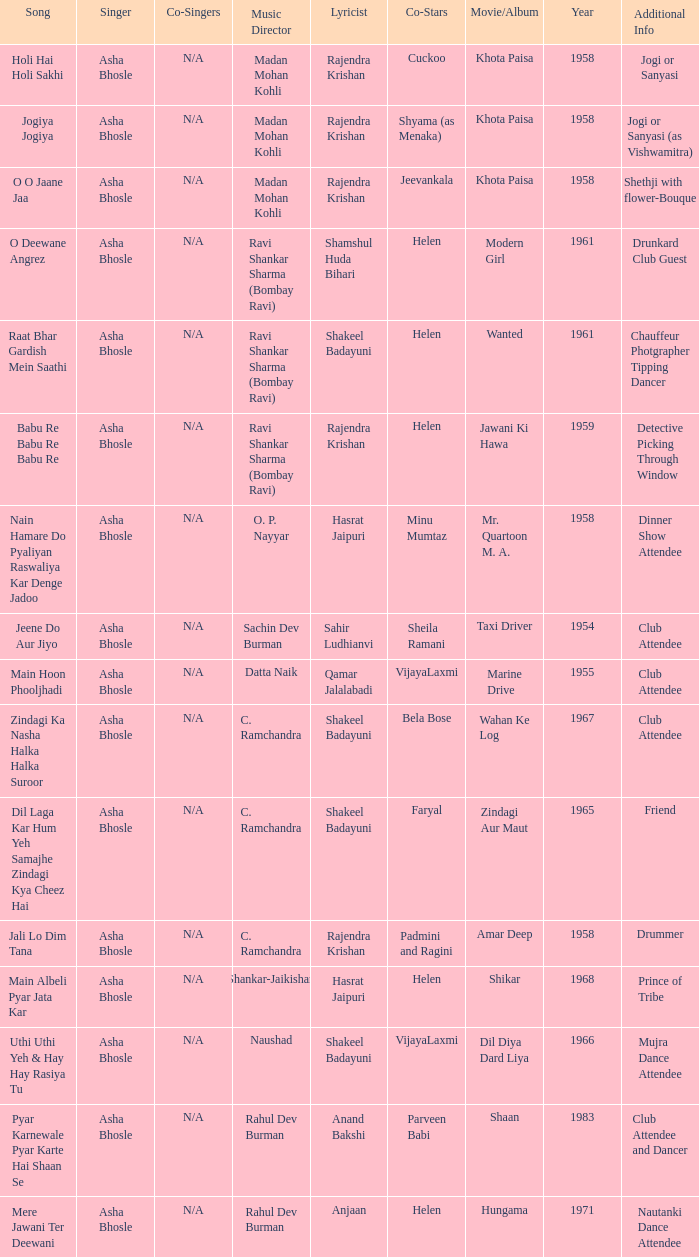Who authored the verses when jeevankala co-acted? Rajendra Krishan. Write the full table. {'header': ['Song', 'Singer', 'Co-Singers', 'Music Director', 'Lyricist', 'Co-Stars', 'Movie/Album', 'Year', 'Additional Info'], 'rows': [['Holi Hai Holi Sakhi', 'Asha Bhosle', 'N/A', 'Madan Mohan Kohli', 'Rajendra Krishan', 'Cuckoo', 'Khota Paisa', '1958', 'Jogi or Sanyasi'], ['Jogiya Jogiya', 'Asha Bhosle', 'N/A', 'Madan Mohan Kohli', 'Rajendra Krishan', 'Shyama (as Menaka)', 'Khota Paisa', '1958', 'Jogi or Sanyasi (as Vishwamitra)'], ['O O Jaane Jaa', 'Asha Bhosle', 'N/A', 'Madan Mohan Kohli', 'Rajendra Krishan', 'Jeevankala', 'Khota Paisa', '1958', 'Shethji with flower-Bouque'], ['O Deewane Angrez', 'Asha Bhosle', 'N/A', 'Ravi Shankar Sharma (Bombay Ravi)', 'Shamshul Huda Bihari', 'Helen', 'Modern Girl', '1961', 'Drunkard Club Guest'], ['Raat Bhar Gardish Mein Saathi', 'Asha Bhosle', 'N/A', 'Ravi Shankar Sharma (Bombay Ravi)', 'Shakeel Badayuni', 'Helen', 'Wanted', '1961', 'Chauffeur Photgrapher Tipping Dancer'], ['Babu Re Babu Re Babu Re', 'Asha Bhosle', 'N/A', 'Ravi Shankar Sharma (Bombay Ravi)', 'Rajendra Krishan', 'Helen', 'Jawani Ki Hawa', '1959', 'Detective Picking Through Window'], ['Nain Hamare Do Pyaliyan Raswaliya Kar Denge Jadoo', 'Asha Bhosle', 'N/A', 'O. P. Nayyar', 'Hasrat Jaipuri', 'Minu Mumtaz', 'Mr. Quartoon M. A.', '1958', 'Dinner Show Attendee'], ['Jeene Do Aur Jiyo', 'Asha Bhosle', 'N/A', 'Sachin Dev Burman', 'Sahir Ludhianvi', 'Sheila Ramani', 'Taxi Driver', '1954', 'Club Attendee'], ['Main Hoon Phooljhadi', 'Asha Bhosle', 'N/A', 'Datta Naik', 'Qamar Jalalabadi', 'VijayaLaxmi', 'Marine Drive', '1955', 'Club Attendee'], ['Zindagi Ka Nasha Halka Halka Suroor', 'Asha Bhosle', 'N/A', 'C. Ramchandra', 'Shakeel Badayuni', 'Bela Bose', 'Wahan Ke Log', '1967', 'Club Attendee'], ['Dil Laga Kar Hum Yeh Samajhe Zindagi Kya Cheez Hai', 'Asha Bhosle', 'N/A', 'C. Ramchandra', 'Shakeel Badayuni', 'Faryal', 'Zindagi Aur Maut', '1965', 'Friend'], ['Jali Lo Dim Tana', 'Asha Bhosle', 'N/A', 'C. Ramchandra', 'Rajendra Krishan', 'Padmini and Ragini', 'Amar Deep', '1958', 'Drummer'], ['Main Albeli Pyar Jata Kar', 'Asha Bhosle', 'N/A', 'Shankar-Jaikishan', 'Hasrat Jaipuri', 'Helen', 'Shikar', '1968', 'Prince of Tribe'], ['Uthi Uthi Yeh & Hay Hay Rasiya Tu', 'Asha Bhosle', 'N/A', 'Naushad', 'Shakeel Badayuni', 'VijayaLaxmi', 'Dil Diya Dard Liya', '1966', 'Mujra Dance Attendee'], ['Pyar Karnewale Pyar Karte Hai Shaan Se', 'Asha Bhosle', 'N/A', 'Rahul Dev Burman', 'Anand Bakshi', 'Parveen Babi', 'Shaan', '1983', 'Club Attendee and Dancer'], ['Mere Jawani Ter Deewani', 'Asha Bhosle', 'N/A', 'Rahul Dev Burman', 'Anjaan', 'Helen', 'Hungama', '1971', 'Nautanki Dance Attendee']]} 